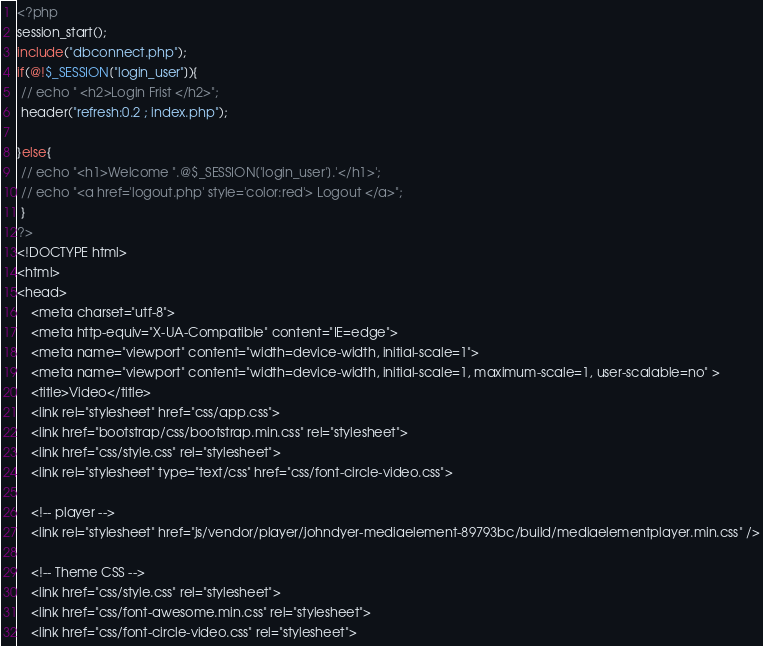Convert code to text. <code><loc_0><loc_0><loc_500><loc_500><_PHP_><?php
session_start();
include("dbconnect.php");
if(@!$_SESSION["login_user"]){
 // echo " <h2>Login Frist </h2>";
 header("refresh:0.2 ; index.php");

}else{
 // echo "<h1>Welcome ".@$_SESSION['login_user'].'</h1>';
 // echo "<a href='logout.php' style='color:red'> Logout </a>";
 }
?>
<!DOCTYPE html>
<html>
<head>
	<meta charset="utf-8">
	<meta http-equiv="X-UA-Compatible" content="IE=edge">
    <meta name="viewport" content="width=device-width, initial-scale=1">
    <meta name="viewport" content="width=device-width, initial-scale=1, maximum-scale=1, user-scalable=no" >
	<title>Video</title>
	<link rel="stylesheet" href="css/app.css">
	<link href="bootstrap/css/bootstrap.min.css" rel="stylesheet">
    <link href="css/style.css" rel="stylesheet">
    <link rel="stylesheet" type="text/css" href="css/font-circle-video.css">
    
    <!-- player -->
    <link rel="stylesheet" href="js/vendor/player/johndyer-mediaelement-89793bc/build/mediaelementplayer.min.css" />

    <!-- Theme CSS -->
    <link href="css/style.css" rel="stylesheet">
    <link href="css/font-awesome.min.css" rel="stylesheet">
    <link href="css/font-circle-video.css" rel="stylesheet"></code> 